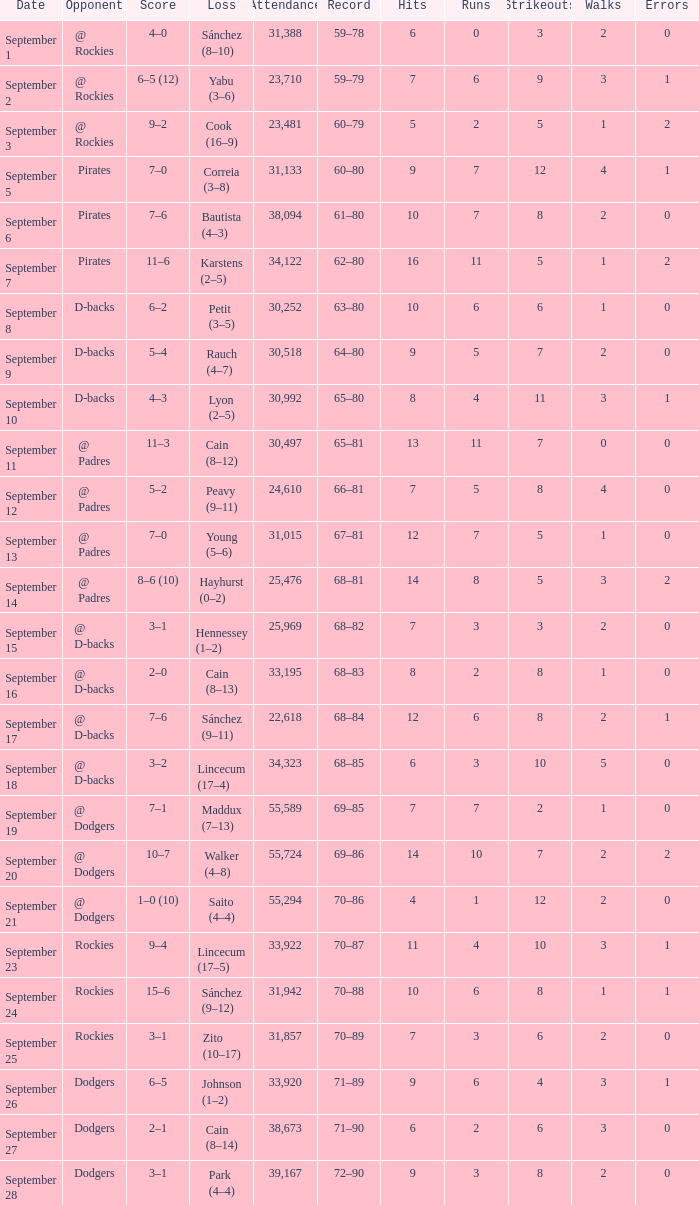What was the attendance on September 28? 39167.0. 